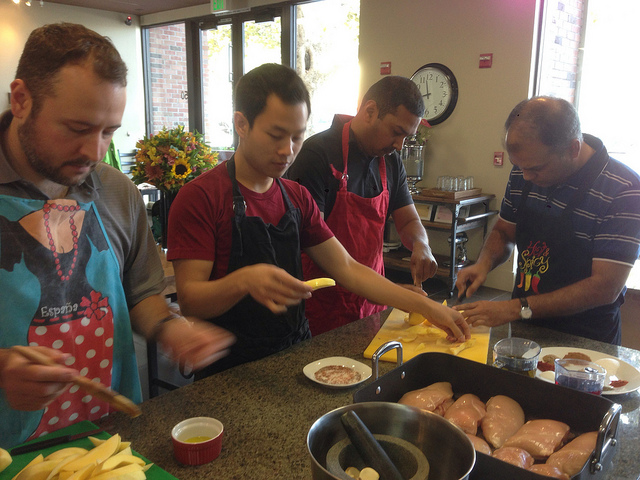Is there anything in the picture that tells us about the time or location of the activity? There's a clock in the background indicating it's about ten minutes to ten, although it doesn't specify AM or PM. As for the location, there are no explicit indicators, but the style of the kitchen, the type of ingredients, and the dress suggest a casual, communal kitchen in a non-professional setting, possibly in a cultural or learning center. 